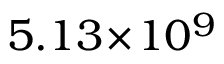Convert formula to latex. <formula><loc_0><loc_0><loc_500><loc_500>5 . 1 3 \, \times \, 1 0 ^ { 9 }</formula> 